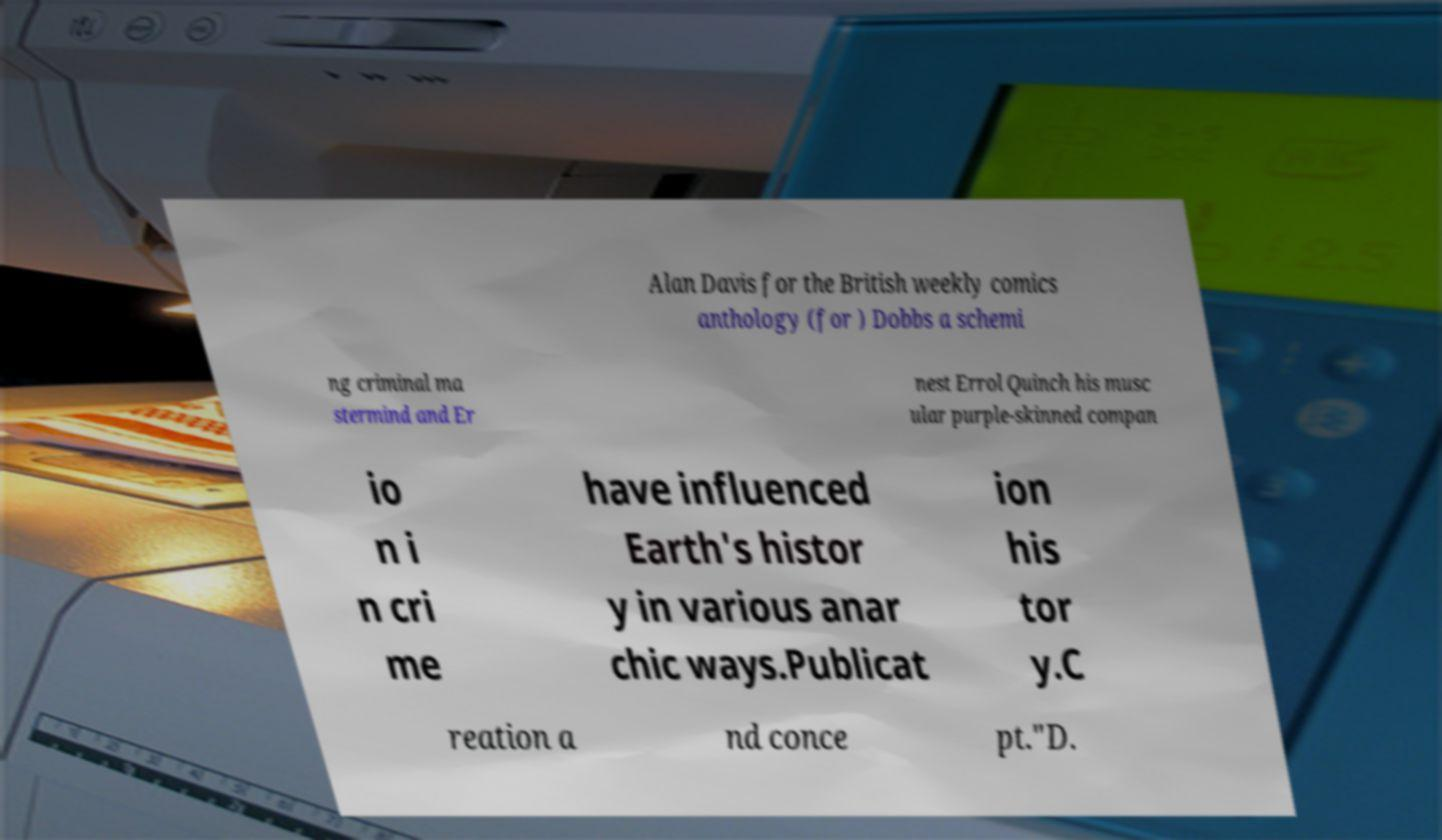What messages or text are displayed in this image? I need them in a readable, typed format. Alan Davis for the British weekly comics anthology (for ) Dobbs a schemi ng criminal ma stermind and Er nest Errol Quinch his musc ular purple-skinned compan io n i n cri me have influenced Earth's histor y in various anar chic ways.Publicat ion his tor y.C reation a nd conce pt."D. 